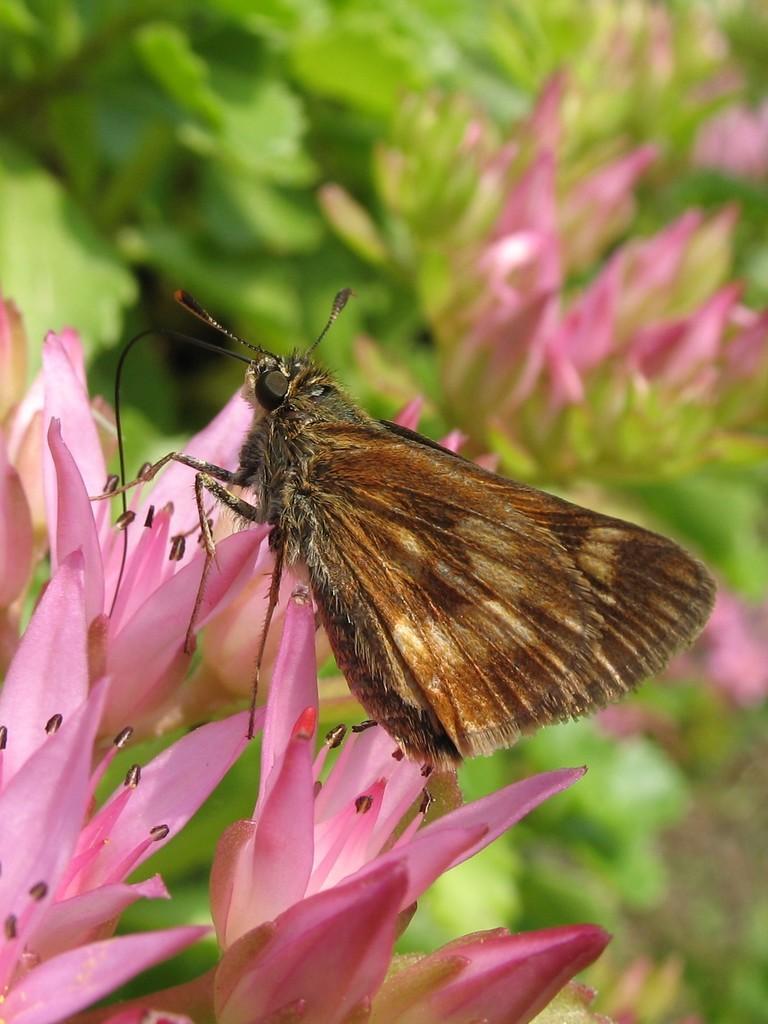Can you describe this image briefly? In this picture we can see a butterfly, flowers and in the background we can see plants. 